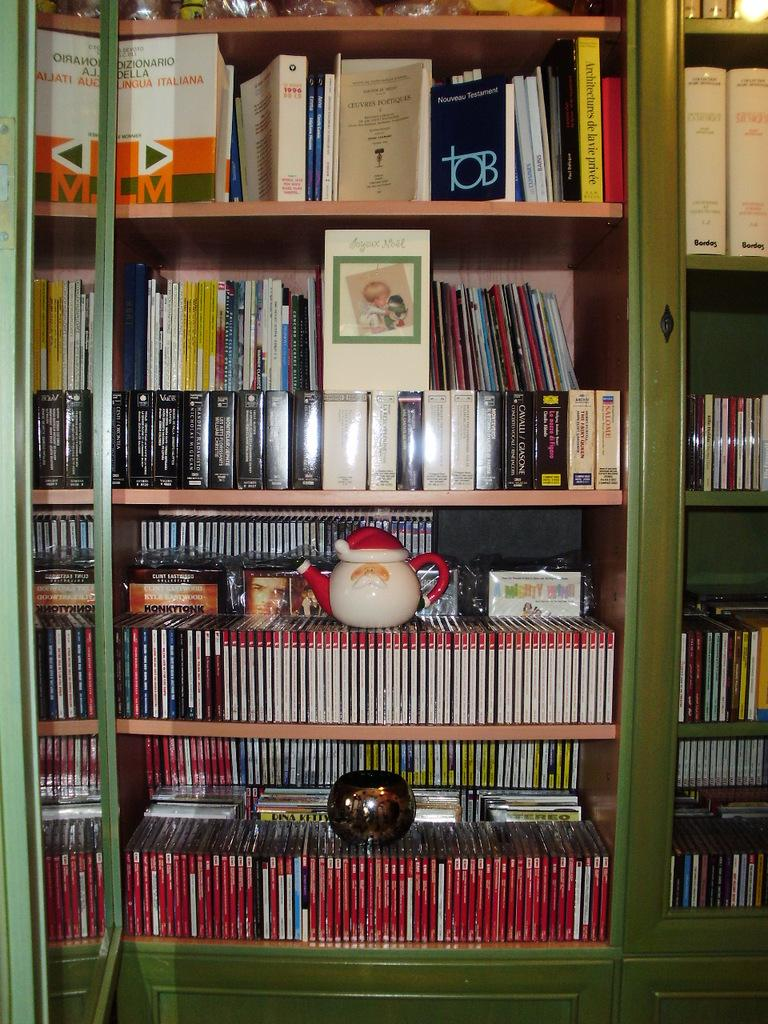What can be seen in the image that is used for storing books? There is a book rack in the image. What is another object visible in the image that is related to preparing hot beverages? There is a kettle in the image. What type of coal is stored in the frame in the image? There is no coal or frame present in the image. 